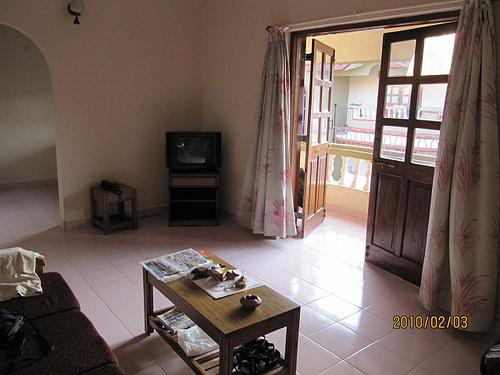How many objects are on the coffee table, and what are they? Two objects are on the coffee table: an ashtray and a newspaper. Identify the color and material of the door in the image. The door is wooden and brown in color. What color are the drapes on the window in this image? The drapes on the window are white and pink. Describe the color and the state of the television in the living room. The television is black and it's turned off. List any reading materials visible in the image. A newspaper and a white magazine are visible in the image. Name three objects that are black in color in the scene. A black TV, a black phone, and black wires are in the scene. Can you please provide the color and material of the couch and the coffee table? The couch is brown in color and the coffee table is wooden. Can you please tell me which objects are visible on the coffee table in this picture? An ashtray and a newspaper can be seen on the coffee table. What type of flooring is observed in the room? The floor is a white-tiled floor. Mention the color of the wall and floor in this room. The wall is light pink in color and the floor is brown. Is the door covering the entire image with a bright green color? The door is not covering the entire image, and it is not mentioned to be bright green in color. It is described as wooden and brown in color. Are the curtains on the window a single, solid shade of blue, and cover only a small part of the window? The curtains described are white and pink, not a solid shade of blue. Additionally, it is not mentioned that they cover only a small part of the window. Does the wooden coffee table have large polka dots pattern and is it floating in mid-air? There is no mention of the wooden coffee table having polka dots pattern, and it is not described as floating in mid-air. It is said to be on a tile floor. Is there a giant purple elephant in the room taking up the majority of the space? There is no mention of a giant purple elephant taking up space in the image. This instruction is completely unrelated to the objects and attributes listed. Can you find a large, square-shaped, red couch in the center of the image? The couch is not mentioned to be large, square-shaped, or red. It is described as brown in color and there is no information about its position in the center of the image.  Can you see a massive chandelier hanging from the ceiling that is dominating the entire scene? There is only a mention of a light fixture on the wall, not a massive chandelier hanging from the ceiling that dominates the scene. The instruction is not consistent with the information given. 